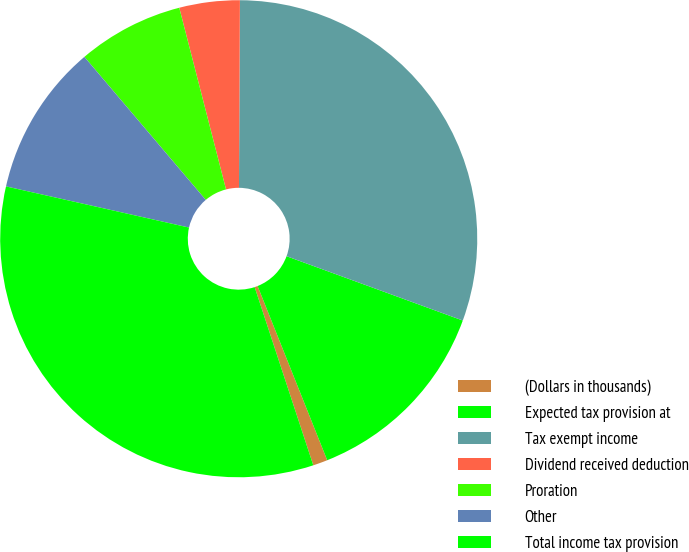Convert chart to OTSL. <chart><loc_0><loc_0><loc_500><loc_500><pie_chart><fcel>(Dollars in thousands)<fcel>Expected tax provision at<fcel>Tax exempt income<fcel>Dividend received deduction<fcel>Proration<fcel>Other<fcel>Total income tax provision<nl><fcel>0.99%<fcel>13.38%<fcel>30.49%<fcel>4.09%<fcel>7.19%<fcel>10.28%<fcel>33.58%<nl></chart> 